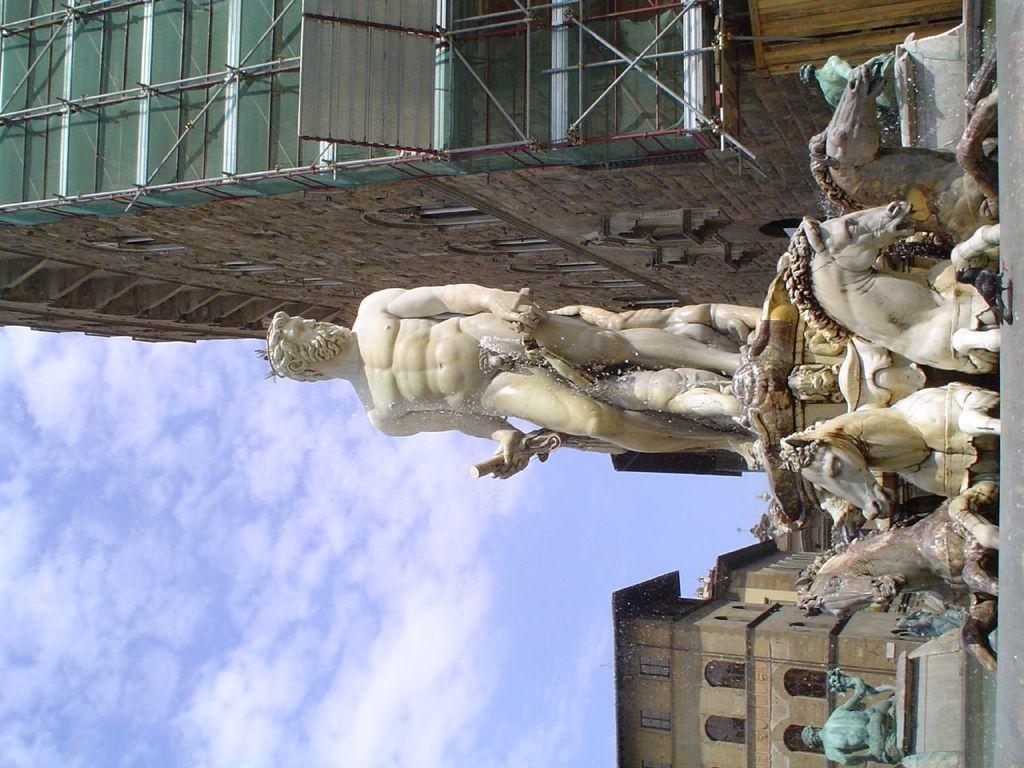Please provide a concise description of this image. To the right side of the image there is a statue of horses and a man. To the top of the image there is a building with glass windows, roofs and brick walls. And to the bottom of the image there is a statue and behind the statue there is a house with roofs and windows. And to the left side bottom of the image there is a sky with clouds. 